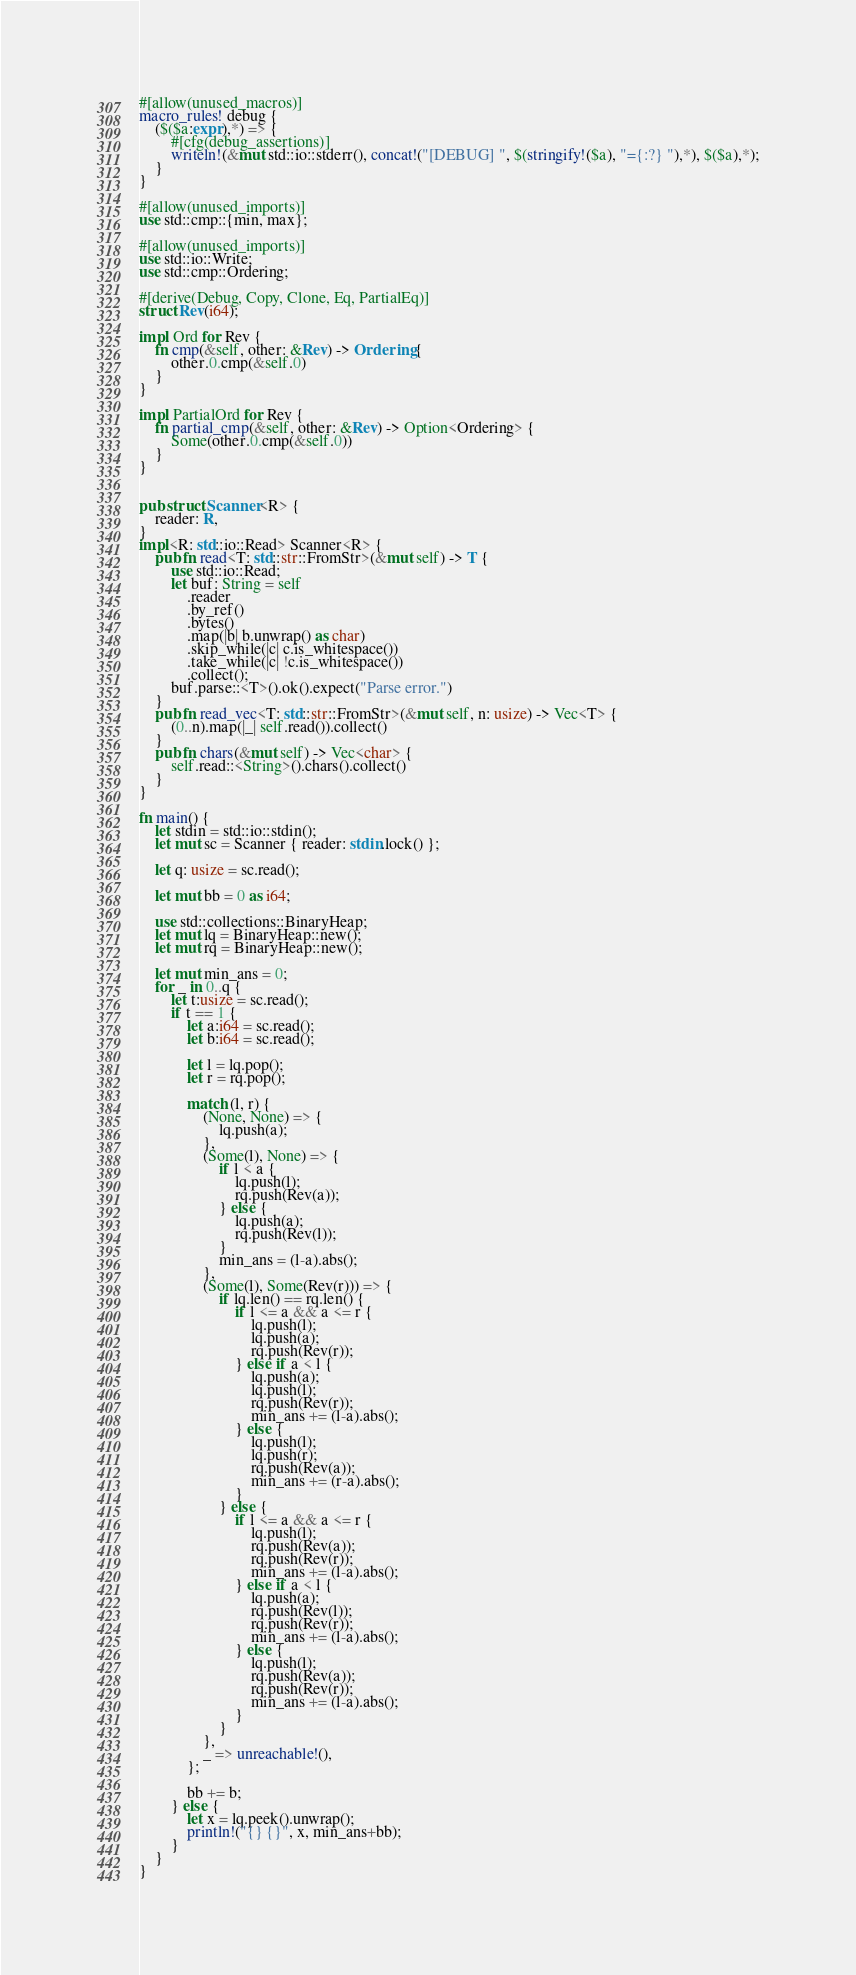<code> <loc_0><loc_0><loc_500><loc_500><_Rust_>#[allow(unused_macros)]
macro_rules! debug {
    ($($a:expr),*) => {
        #[cfg(debug_assertions)]
        writeln!(&mut std::io::stderr(), concat!("[DEBUG] ", $(stringify!($a), "={:?} "),*), $($a),*);
    }
}

#[allow(unused_imports)]
use std::cmp::{min, max};

#[allow(unused_imports)]
use std::io::Write;
use std::cmp::Ordering;

#[derive(Debug, Copy, Clone, Eq, PartialEq)]
struct Rev(i64);

impl Ord for Rev {
    fn cmp(&self, other: &Rev) -> Ordering {
        other.0.cmp(&self.0)
    }
}

impl PartialOrd for Rev {
    fn partial_cmp(&self, other: &Rev) -> Option<Ordering> {
        Some(other.0.cmp(&self.0))
    }
}


pub struct Scanner<R> {
    reader: R,
}
impl<R: std::io::Read> Scanner<R> {
    pub fn read<T: std::str::FromStr>(&mut self) -> T {
        use std::io::Read;
        let buf: String = self
            .reader
            .by_ref()
            .bytes()
            .map(|b| b.unwrap() as char)
            .skip_while(|c| c.is_whitespace())
            .take_while(|c| !c.is_whitespace())
            .collect();
        buf.parse::<T>().ok().expect("Parse error.")
    }
    pub fn read_vec<T: std::str::FromStr>(&mut self, n: usize) -> Vec<T> {
        (0..n).map(|_| self.read()).collect()
    }
    pub fn chars(&mut self) -> Vec<char> {
        self.read::<String>().chars().collect()
    }
}

fn main() {
    let stdin = std::io::stdin();
    let mut sc = Scanner { reader: stdin.lock() };

    let q: usize = sc.read();

    let mut bb = 0 as i64;

    use std::collections::BinaryHeap;
    let mut lq = BinaryHeap::new();
    let mut rq = BinaryHeap::new();

    let mut min_ans = 0;
    for _ in 0..q {
        let t:usize = sc.read();
        if t == 1 {
            let a:i64 = sc.read();
            let b:i64 = sc.read();

            let l = lq.pop();
            let r = rq.pop();

            match (l, r) {
                (None, None) => {
                    lq.push(a);
                },
                (Some(l), None) => {
                    if l < a {
                        lq.push(l);
                        rq.push(Rev(a));
                    } else {
                        lq.push(a);
                        rq.push(Rev(l));
                    }
                    min_ans = (l-a).abs();
                },
                (Some(l), Some(Rev(r))) => {
                    if lq.len() == rq.len() {
                        if l <= a && a <= r {
                            lq.push(l);
                            lq.push(a);
                            rq.push(Rev(r));
                        } else if a < l {
                            lq.push(a);
                            lq.push(l);
                            rq.push(Rev(r));
                            min_ans += (l-a).abs();
                        } else {
                            lq.push(l);
                            lq.push(r);
                            rq.push(Rev(a));
                            min_ans += (r-a).abs();
                        }
                    } else {
                        if l <= a && a <= r {
                            lq.push(l);
                            rq.push(Rev(a));
                            rq.push(Rev(r));
                            min_ans += (l-a).abs();
                        } else if a < l {
                            lq.push(a);
                            rq.push(Rev(l));
                            rq.push(Rev(r));
                            min_ans += (l-a).abs();
                        } else {
                            lq.push(l);
                            rq.push(Rev(a));
                            rq.push(Rev(r));
                            min_ans += (l-a).abs();
                        }
                    }
                },
                _ => unreachable!(),
            };

            bb += b;
        } else {
            let x = lq.peek().unwrap();
            println!("{} {}", x, min_ans+bb);
        }
    }
}
</code> 